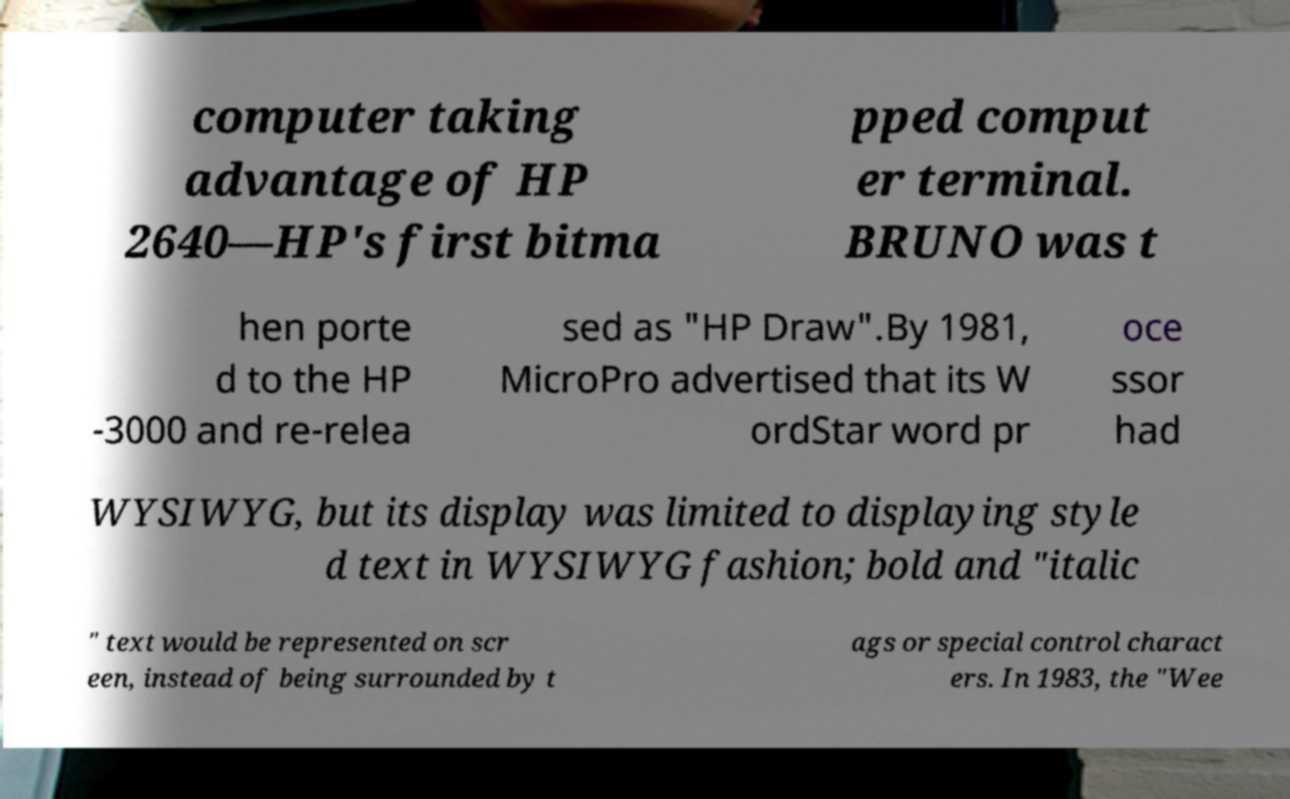Could you extract and type out the text from this image? computer taking advantage of HP 2640—HP's first bitma pped comput er terminal. BRUNO was t hen porte d to the HP -3000 and re-relea sed as "HP Draw".By 1981, MicroPro advertised that its W ordStar word pr oce ssor had WYSIWYG, but its display was limited to displaying style d text in WYSIWYG fashion; bold and "italic " text would be represented on scr een, instead of being surrounded by t ags or special control charact ers. In 1983, the "Wee 